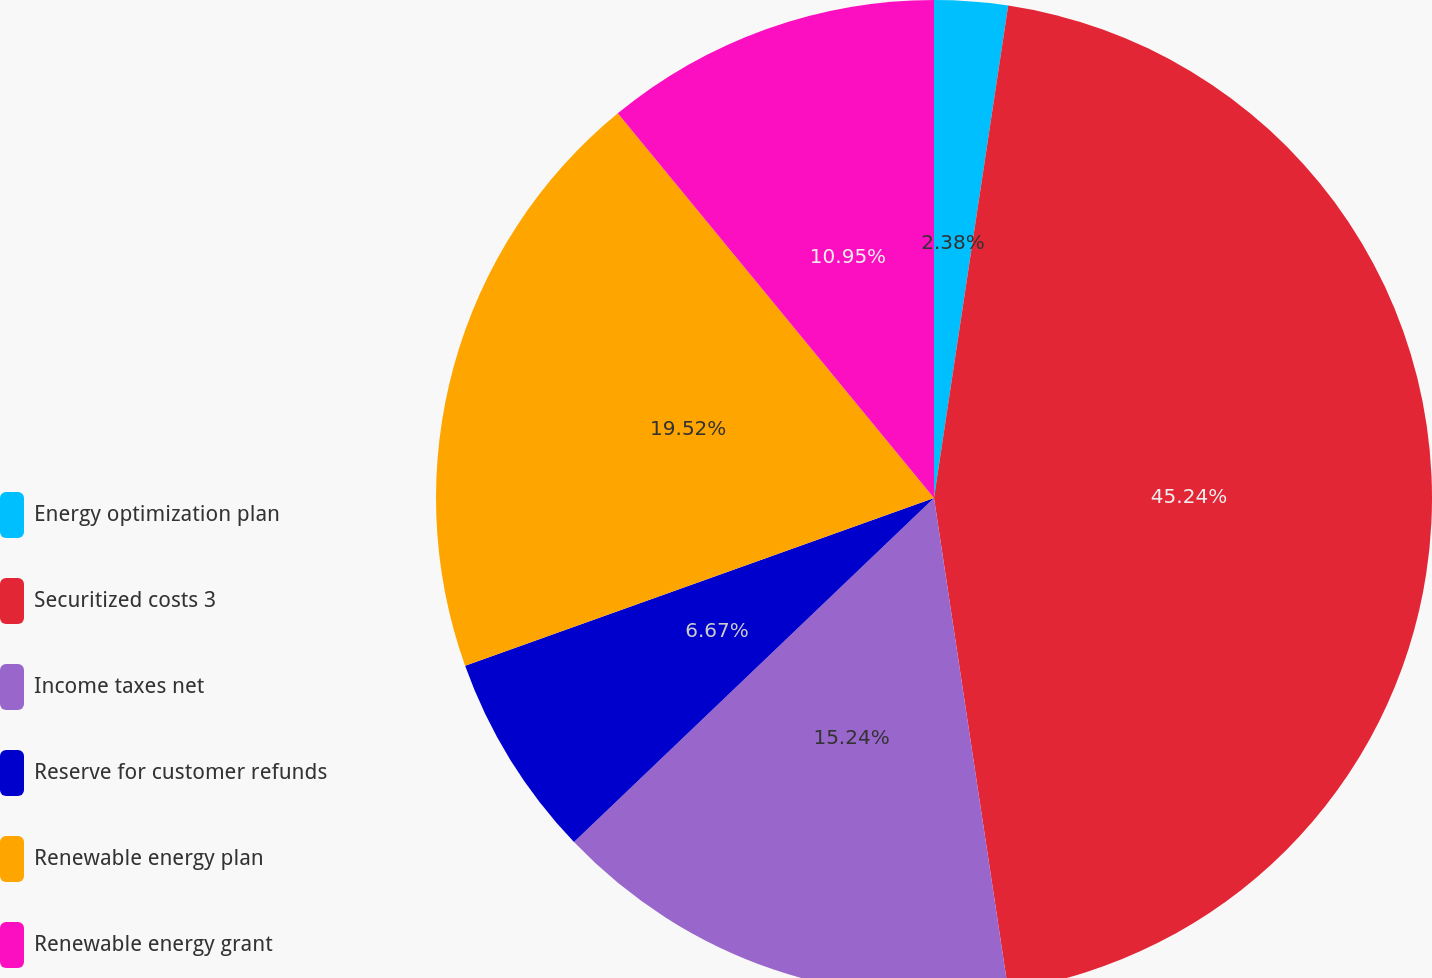<chart> <loc_0><loc_0><loc_500><loc_500><pie_chart><fcel>Energy optimization plan<fcel>Securitized costs 3<fcel>Income taxes net<fcel>Reserve for customer refunds<fcel>Renewable energy plan<fcel>Renewable energy grant<nl><fcel>2.38%<fcel>45.24%<fcel>15.24%<fcel>6.67%<fcel>19.52%<fcel>10.95%<nl></chart> 